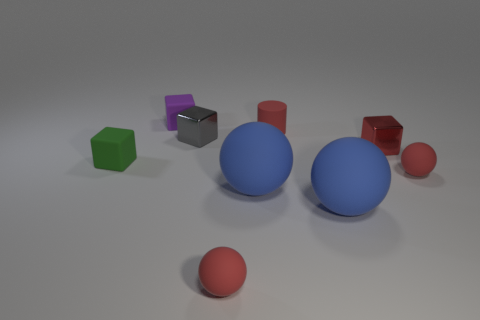Subtract all gray shiny blocks. How many blocks are left? 3 Add 1 green blocks. How many objects exist? 10 Subtract all cyan balls. Subtract all purple blocks. How many balls are left? 4 Subtract all balls. How many objects are left? 5 Subtract 0 brown cylinders. How many objects are left? 9 Subtract all tiny gray cubes. Subtract all small matte objects. How many objects are left? 3 Add 8 small gray blocks. How many small gray blocks are left? 9 Add 3 big red matte blocks. How many big red matte blocks exist? 3 